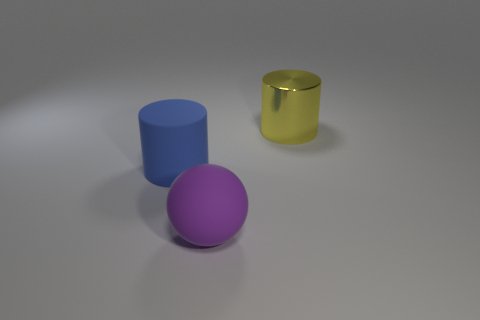Is there anything else that is the same shape as the large metal thing?
Offer a very short reply. Yes. What is the color of the other thing that is the same shape as the large yellow metallic thing?
Offer a very short reply. Blue. Does the yellow cylinder have the same size as the purple thing?
Make the answer very short. Yes. What number of things are either large things to the left of the large yellow metallic thing or large cylinders to the right of the large purple rubber sphere?
Provide a succinct answer. 3. What is the shape of the purple matte thing that is the same size as the metal object?
Make the answer very short. Sphere. There is a purple thing that is made of the same material as the blue thing; what size is it?
Your answer should be compact. Large. Do the large purple object and the blue matte object have the same shape?
Your answer should be very brief. No. There is a ball that is the same size as the shiny object; what color is it?
Your answer should be compact. Purple. What is the size of the other metallic object that is the same shape as the big blue object?
Keep it short and to the point. Large. The large matte object to the left of the purple ball has what shape?
Make the answer very short. Cylinder. 